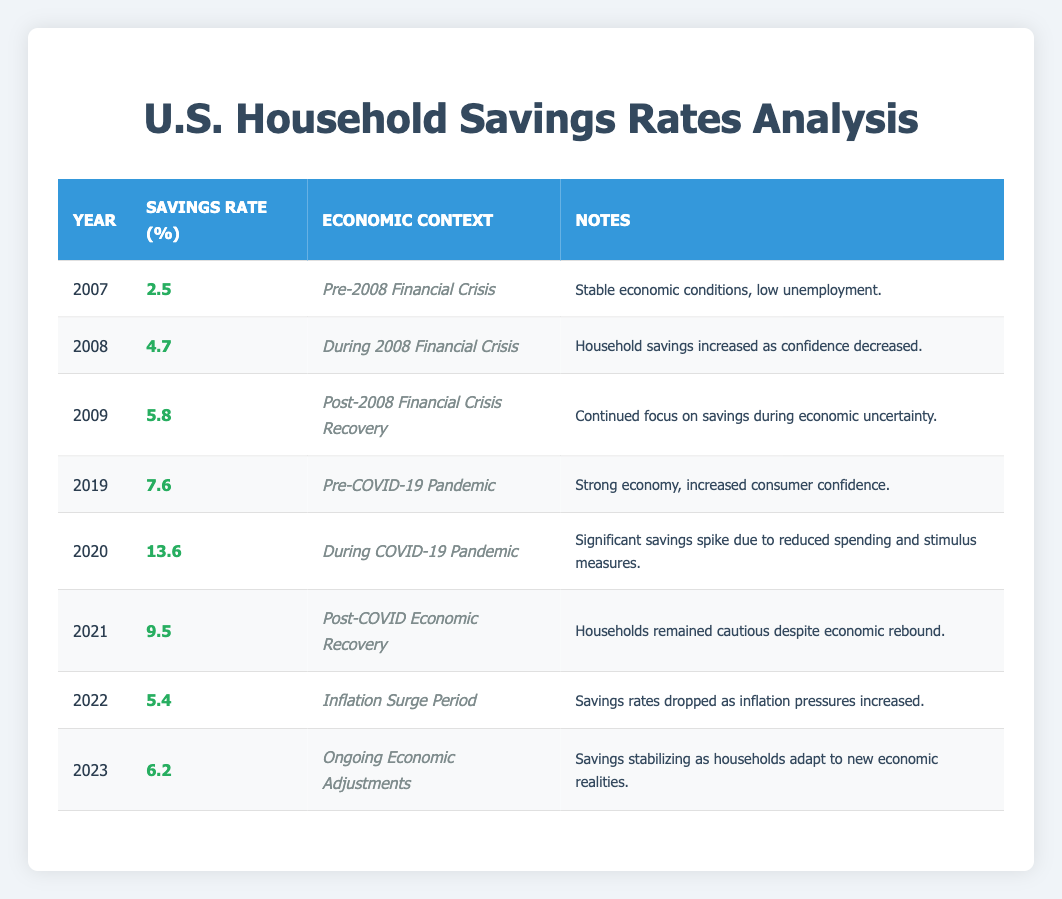What was the household savings rate in 2020? The table shows that in the year 2020, the savings rate was 13.6%.
Answer: 13.6 How did the savings rate change from 2007 to 2009? In 2007, the savings rate was 2.5%, and by 2009 it had increased to 5.8%. This indicates an increase of 3.3 percentage points over two years.
Answer: Increased by 3.3 percentage points Was there a spike in savings rates during the COVID-19 pandemic? Yes, the savings rate increased significantly from 7.6% in 2019 to 13.6% in 2020, indicating a spike during the pandemic.
Answer: Yes What was the average savings rate from 2008 to 2021? To find the average, add the savings rates from 2008 (4.7), 2009 (5.8), 2019 (7.6), 2020 (13.6), and 2021 (9.5) which totals 41.2. There are five data points, so the average is 41.2/5 = 8.24%.
Answer: 8.24 Did the savings rate in 2022 drop below that of 2008? Yes, the savings rate in 2022 was 5.4%, which is lower than the 4.7% in 2008.
Answer: Yes What was the highest savings rate recorded in the table? The highest recorded savings rate in the table is 13.6% in 2020.
Answer: 13.6 How do the savings rates from 2021 and 2022 compare? The savings rate in 2021 was 9.5%, while in 2022 it dropped to 5.4%. This shows a decrease of 4.1 percentage points from 2021 to 2022.
Answer: Decreased by 4.1 percentage points What year saw the lowest savings rate after the 2008 financial crisis? The lowest savings rate after the 2008 financial crisis occurred in 2018, with a rate of 7.6% just prior to the COVID-19 pandemic.
Answer: 2019 Was there ever a year where the savings rate was below 5%? Yes, the savings rate was below 5% only in 2007, which recorded a rate of 2.5%.
Answer: Yes 